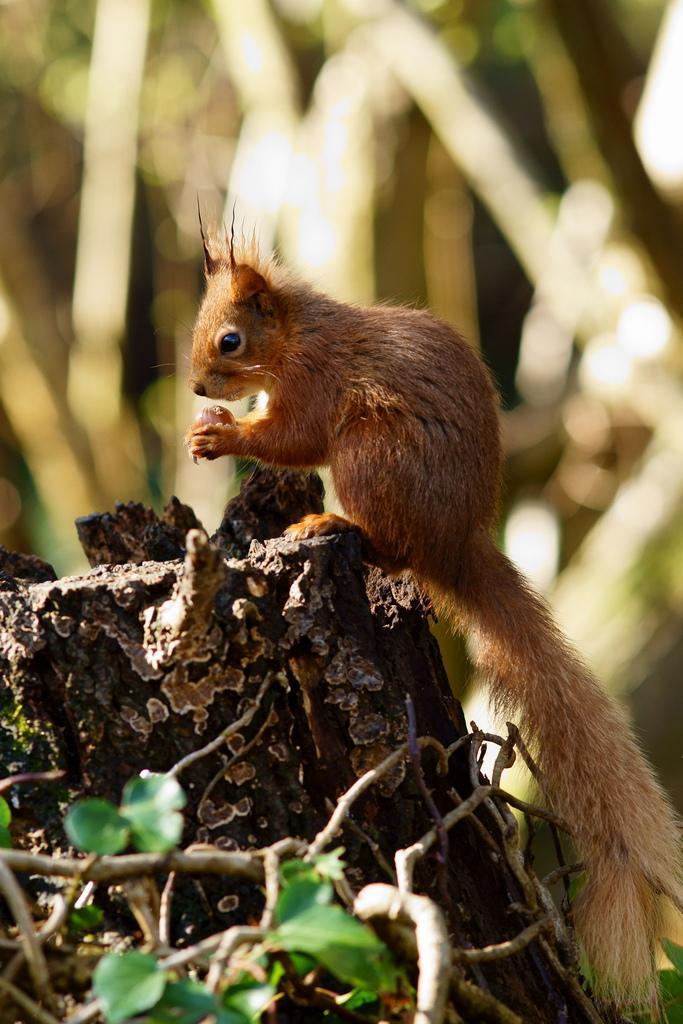Can you describe this image briefly? In this image we can see there is a chipmunk on the wooden object. In the background it is blur. 